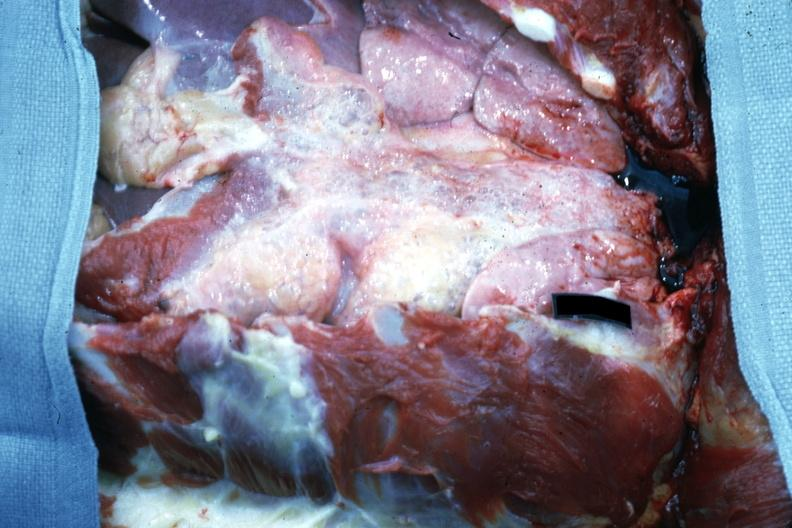s musculoskeletal present?
Answer the question using a single word or phrase. No 